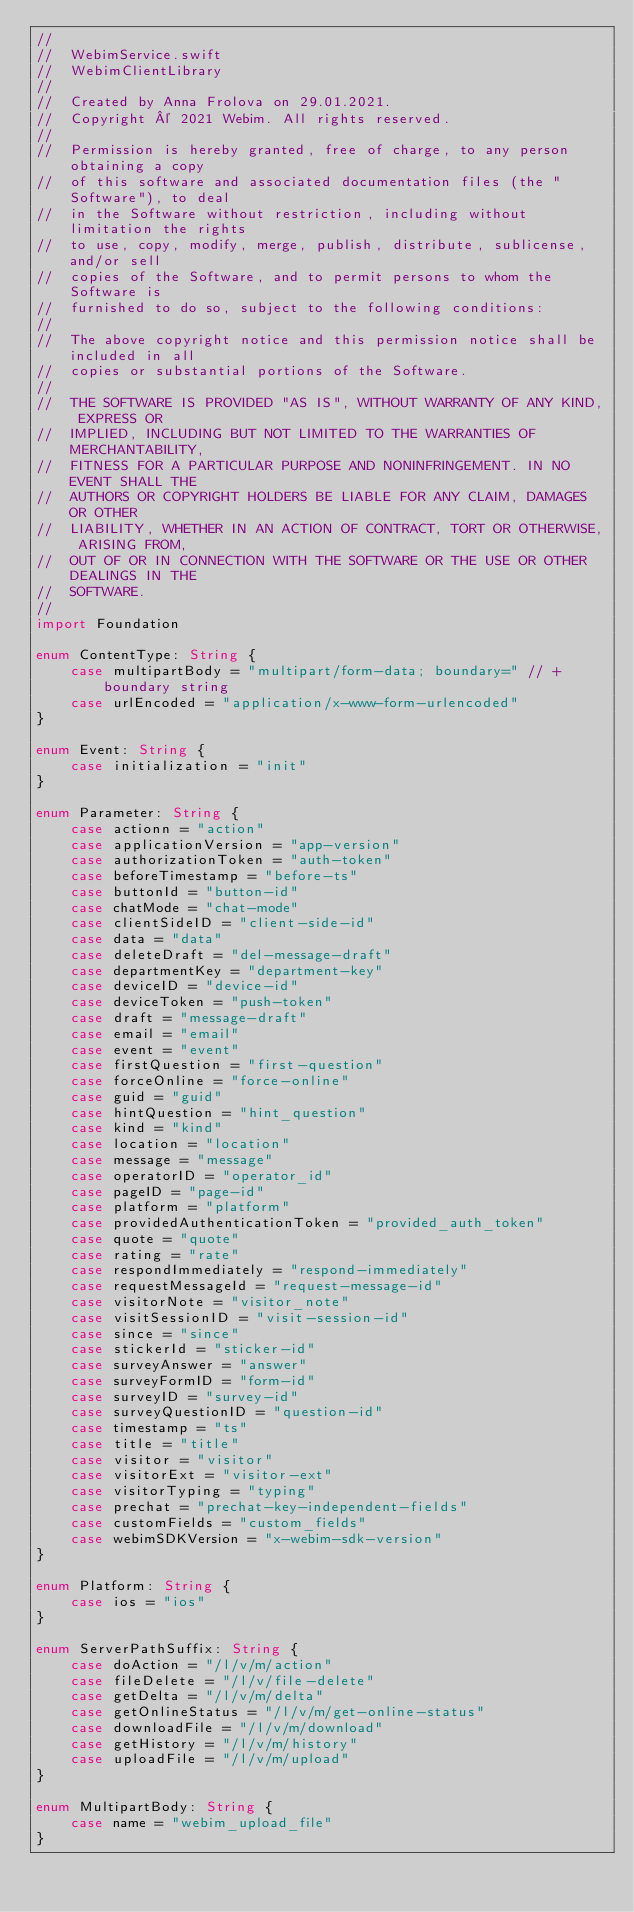<code> <loc_0><loc_0><loc_500><loc_500><_Swift_>//
//  WebimService.swift
//  WebimClientLibrary
//
//  Created by Anna Frolova on 29.01.2021.
//  Copyright © 2021 Webim. All rights reserved.
//
//  Permission is hereby granted, free of charge, to any person obtaining a copy
//  of this software and associated documentation files (the "Software"), to deal
//  in the Software without restriction, including without limitation the rights
//  to use, copy, modify, merge, publish, distribute, sublicense, and/or sell
//  copies of the Software, and to permit persons to whom the Software is
//  furnished to do so, subject to the following conditions:
//
//  The above copyright notice and this permission notice shall be included in all
//  copies or substantial portions of the Software.
//
//  THE SOFTWARE IS PROVIDED "AS IS", WITHOUT WARRANTY OF ANY KIND, EXPRESS OR
//  IMPLIED, INCLUDING BUT NOT LIMITED TO THE WARRANTIES OF MERCHANTABILITY,
//  FITNESS FOR A PARTICULAR PURPOSE AND NONINFRINGEMENT. IN NO EVENT SHALL THE
//  AUTHORS OR COPYRIGHT HOLDERS BE LIABLE FOR ANY CLAIM, DAMAGES OR OTHER
//  LIABILITY, WHETHER IN AN ACTION OF CONTRACT, TORT OR OTHERWISE, ARISING FROM,
//  OUT OF OR IN CONNECTION WITH THE SOFTWARE OR THE USE OR OTHER DEALINGS IN THE
//  SOFTWARE.
//
import Foundation

enum ContentType: String {
    case multipartBody = "multipart/form-data; boundary=" // + boundary string
    case urlEncoded = "application/x-www-form-urlencoded"
}

enum Event: String {
    case initialization = "init"
}

enum Parameter: String {
    case actionn = "action"
    case applicationVersion = "app-version"
    case authorizationToken = "auth-token"
    case beforeTimestamp = "before-ts"
    case buttonId = "button-id"
    case chatMode = "chat-mode"
    case clientSideID = "client-side-id"
    case data = "data"
    case deleteDraft = "del-message-draft"
    case departmentKey = "department-key"
    case deviceID = "device-id"
    case deviceToken = "push-token"
    case draft = "message-draft"
    case email = "email"
    case event = "event"
    case firstQuestion = "first-question"
    case forceOnline = "force-online"
    case guid = "guid"
    case hintQuestion = "hint_question"
    case kind = "kind"
    case location = "location"
    case message = "message"
    case operatorID = "operator_id"
    case pageID = "page-id"
    case platform = "platform"
    case providedAuthenticationToken = "provided_auth_token"
    case quote = "quote"
    case rating = "rate"
    case respondImmediately = "respond-immediately"
    case requestMessageId = "request-message-id"
    case visitorNote = "visitor_note"
    case visitSessionID = "visit-session-id"
    case since = "since"
    case stickerId = "sticker-id"
    case surveyAnswer = "answer"
    case surveyFormID = "form-id"
    case surveyID = "survey-id"
    case surveyQuestionID = "question-id"
    case timestamp = "ts"
    case title = "title"
    case visitor = "visitor"
    case visitorExt = "visitor-ext"
    case visitorTyping = "typing"
    case prechat = "prechat-key-independent-fields"
    case customFields = "custom_fields"
    case webimSDKVersion = "x-webim-sdk-version"
}

enum Platform: String {
    case ios = "ios"
}

enum ServerPathSuffix: String {
    case doAction = "/l/v/m/action"
    case fileDelete = "/l/v/file-delete"
    case getDelta = "/l/v/m/delta"
    case getOnlineStatus = "/l/v/m/get-online-status"
    case downloadFile = "/l/v/m/download"
    case getHistory = "/l/v/m/history"
    case uploadFile = "/l/v/m/upload"
}

enum MultipartBody: String {
    case name = "webim_upload_file"
}

</code> 